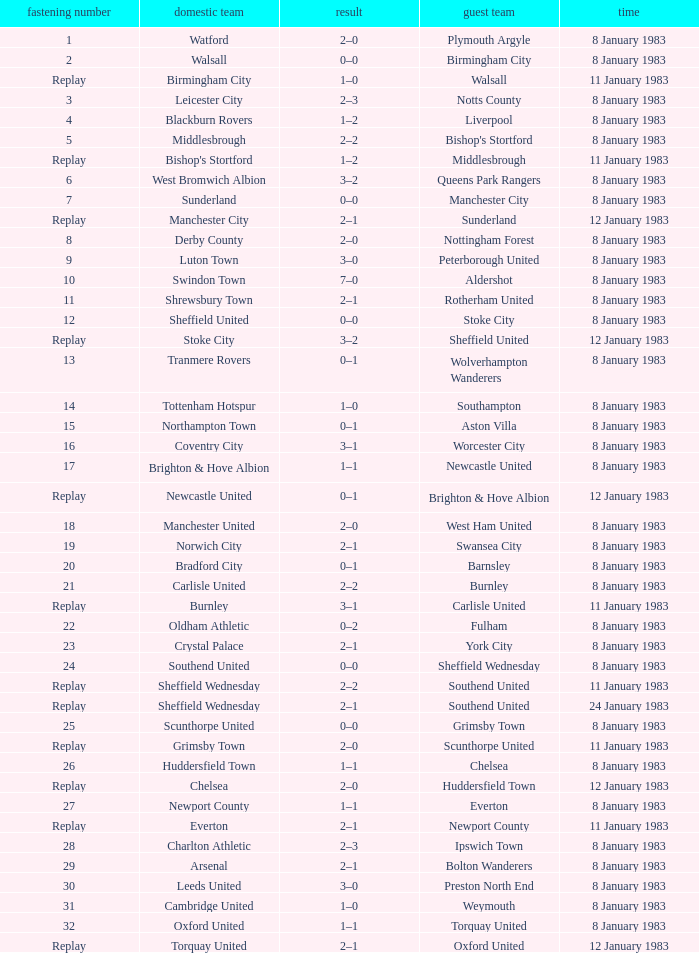On what date was Tie #13 played? 8 January 1983. 